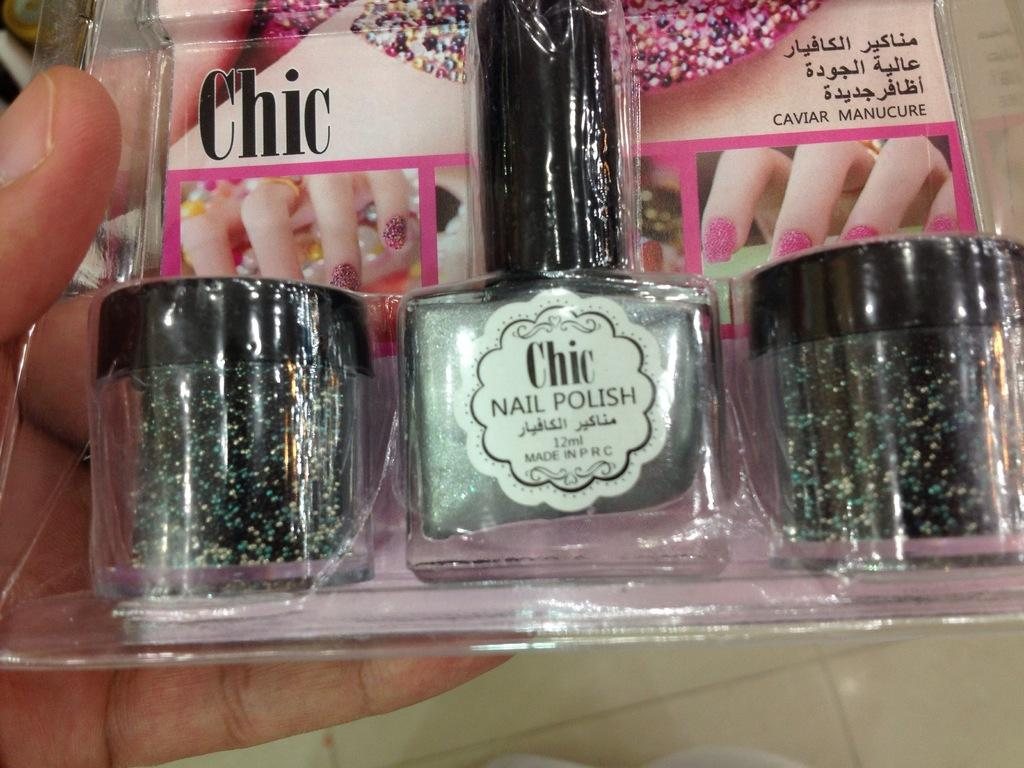<image>
Offer a succinct explanation of the picture presented. A bottle of packaged nail polish from the brand Chic. 